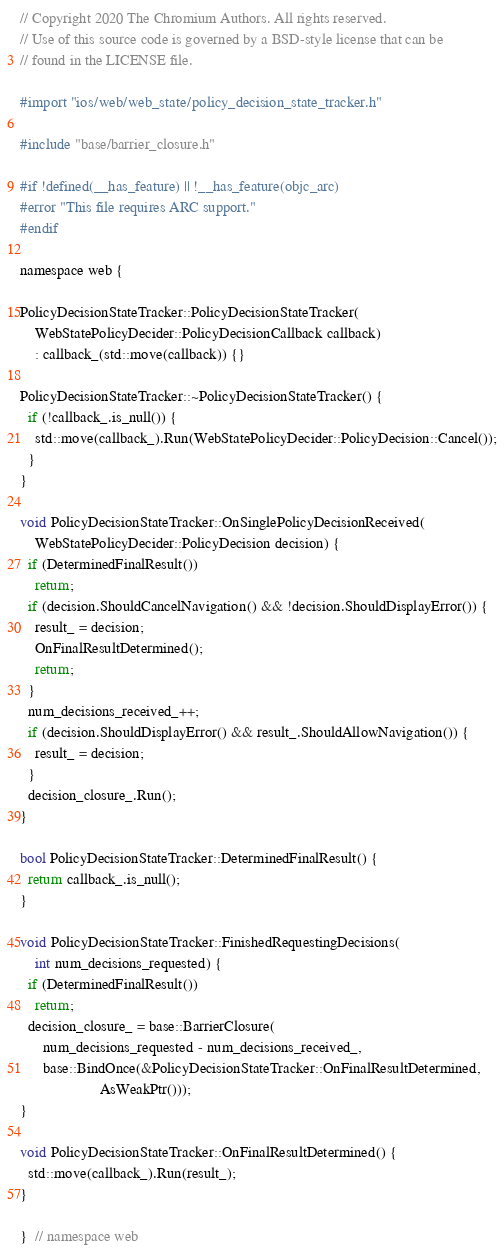Convert code to text. <code><loc_0><loc_0><loc_500><loc_500><_ObjectiveC_>// Copyright 2020 The Chromium Authors. All rights reserved.
// Use of this source code is governed by a BSD-style license that can be
// found in the LICENSE file.

#import "ios/web/web_state/policy_decision_state_tracker.h"

#include "base/barrier_closure.h"

#if !defined(__has_feature) || !__has_feature(objc_arc)
#error "This file requires ARC support."
#endif

namespace web {

PolicyDecisionStateTracker::PolicyDecisionStateTracker(
    WebStatePolicyDecider::PolicyDecisionCallback callback)
    : callback_(std::move(callback)) {}

PolicyDecisionStateTracker::~PolicyDecisionStateTracker() {
  if (!callback_.is_null()) {
    std::move(callback_).Run(WebStatePolicyDecider::PolicyDecision::Cancel());
  }
}

void PolicyDecisionStateTracker::OnSinglePolicyDecisionReceived(
    WebStatePolicyDecider::PolicyDecision decision) {
  if (DeterminedFinalResult())
    return;
  if (decision.ShouldCancelNavigation() && !decision.ShouldDisplayError()) {
    result_ = decision;
    OnFinalResultDetermined();
    return;
  }
  num_decisions_received_++;
  if (decision.ShouldDisplayError() && result_.ShouldAllowNavigation()) {
    result_ = decision;
  }
  decision_closure_.Run();
}

bool PolicyDecisionStateTracker::DeterminedFinalResult() {
  return callback_.is_null();
}

void PolicyDecisionStateTracker::FinishedRequestingDecisions(
    int num_decisions_requested) {
  if (DeterminedFinalResult())
    return;
  decision_closure_ = base::BarrierClosure(
      num_decisions_requested - num_decisions_received_,
      base::BindOnce(&PolicyDecisionStateTracker::OnFinalResultDetermined,
                     AsWeakPtr()));
}

void PolicyDecisionStateTracker::OnFinalResultDetermined() {
  std::move(callback_).Run(result_);
}

}  // namespace web
</code> 